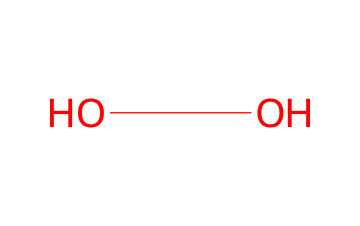What is the molecular formula of this compound? The SMILES representation "OO" indicates that there are two oxygen atoms connected by a single bond. The molecular formula is derived directly from counting these atoms.
Answer: H2O2 How many total atoms are present in this molecule? In the molecular formula H2O2, there are two hydrogen atoms and two oxygen atoms, which gives a total of four atoms.
Answer: 4 What type of bonding is present in hydrogen peroxide? The SMILES "OO" symbolizes a single bond between the two oxygen atoms. Additionally, the presence of hydrogen (in H2O2) indicates that there are also single bonds between the hydrogen and oxygen. Thus, all are single covalent bonds.
Answer: single bond How does hydrogen peroxide act as an oxidizer? The structure of hydrogen peroxide allows it to easily release oxygen when it decomposes (2 H2O2 -> 2 H2O + O2), which can react with and oxidize various substances, making it an effective oxidizing agent.
Answer: releases oxygen What is the effect of hydrogen peroxide on bacteria? Hydrogen peroxide generates reactive oxygen species that can damage microbial proteins and DNA, leading to cell death.
Answer: cell death Is hydrogen peroxide a strong or weak oxidizer? Hydrogen peroxide is considered a strong oxidizer due to its ability to donate oxygen and facilitate oxidation reactions readily.
Answer: strong 